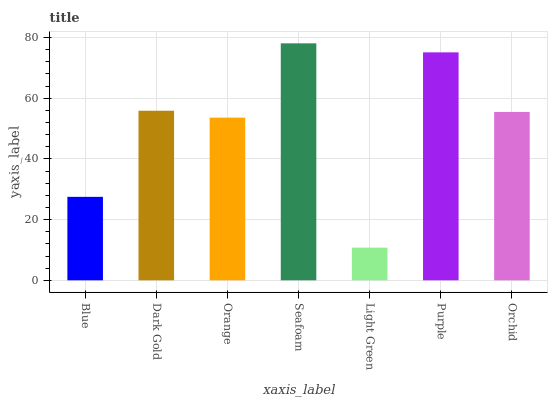Is Dark Gold the minimum?
Answer yes or no. No. Is Dark Gold the maximum?
Answer yes or no. No. Is Dark Gold greater than Blue?
Answer yes or no. Yes. Is Blue less than Dark Gold?
Answer yes or no. Yes. Is Blue greater than Dark Gold?
Answer yes or no. No. Is Dark Gold less than Blue?
Answer yes or no. No. Is Orchid the high median?
Answer yes or no. Yes. Is Orchid the low median?
Answer yes or no. Yes. Is Light Green the high median?
Answer yes or no. No. Is Orange the low median?
Answer yes or no. No. 